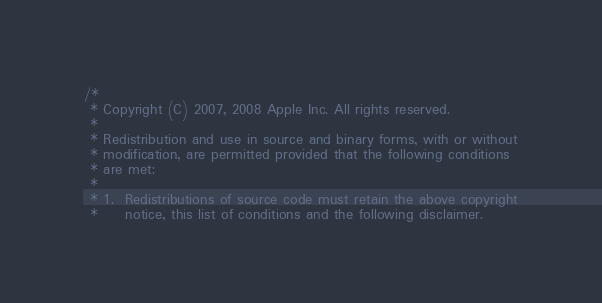<code> <loc_0><loc_0><loc_500><loc_500><_C++_>/*
 * Copyright (C) 2007, 2008 Apple Inc. All rights reserved.
 *
 * Redistribution and use in source and binary forms, with or without
 * modification, are permitted provided that the following conditions
 * are met:
 *
 * 1.  Redistributions of source code must retain the above copyright
 *     notice, this list of conditions and the following disclaimer. </code> 